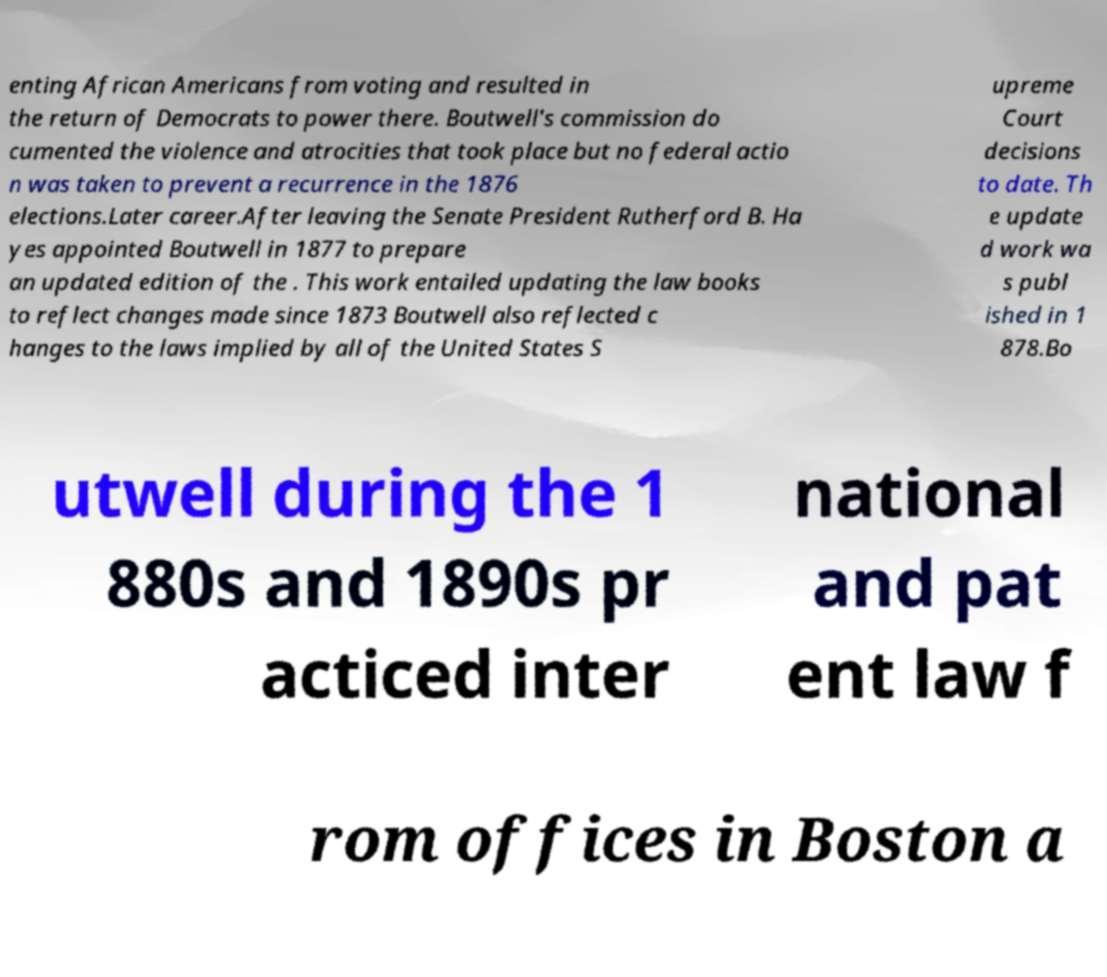There's text embedded in this image that I need extracted. Can you transcribe it verbatim? enting African Americans from voting and resulted in the return of Democrats to power there. Boutwell's commission do cumented the violence and atrocities that took place but no federal actio n was taken to prevent a recurrence in the 1876 elections.Later career.After leaving the Senate President Rutherford B. Ha yes appointed Boutwell in 1877 to prepare an updated edition of the . This work entailed updating the law books to reflect changes made since 1873 Boutwell also reflected c hanges to the laws implied by all of the United States S upreme Court decisions to date. Th e update d work wa s publ ished in 1 878.Bo utwell during the 1 880s and 1890s pr acticed inter national and pat ent law f rom offices in Boston a 